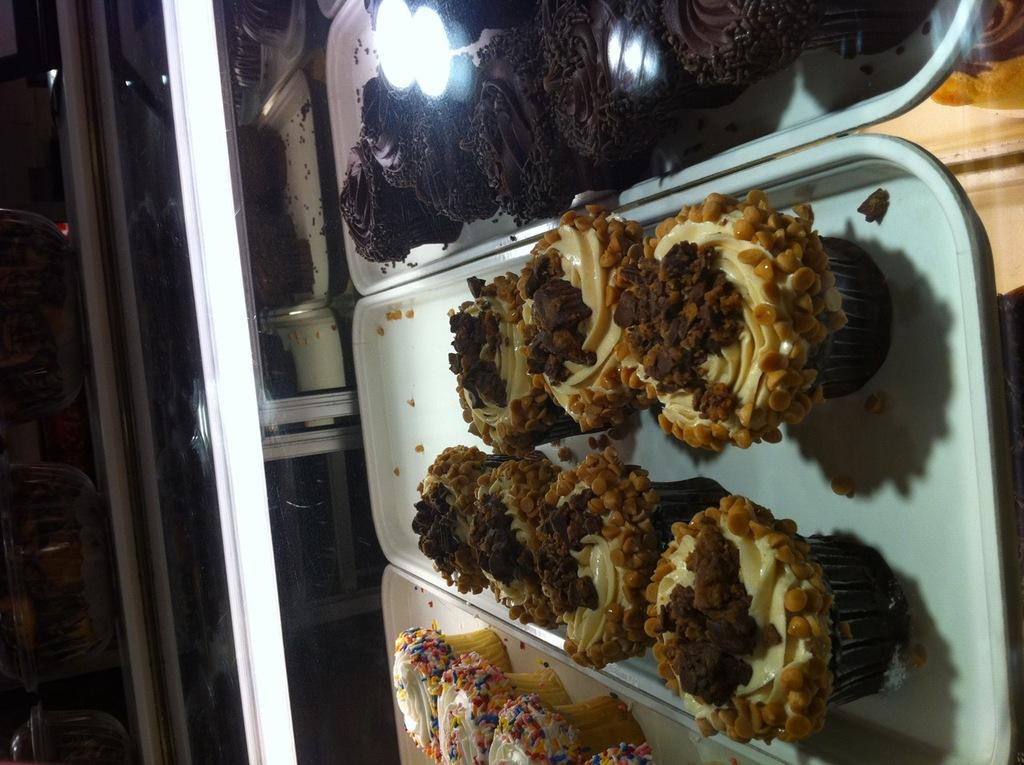What type of food is visible on the trays in the image? There are cupcakes on trays in the image. How are the trays arranged in the image? The trays are placed in a glass shelf. What can be observed about the lighting in the image? The background of the image is dark. How many boys are present in the image? There are no boys visible in the image; it features cupcakes on trays in a glass shelf. What type of room is shown in the image? The image does not show a room; it only displays cupcakes on trays in a glass shelf. 